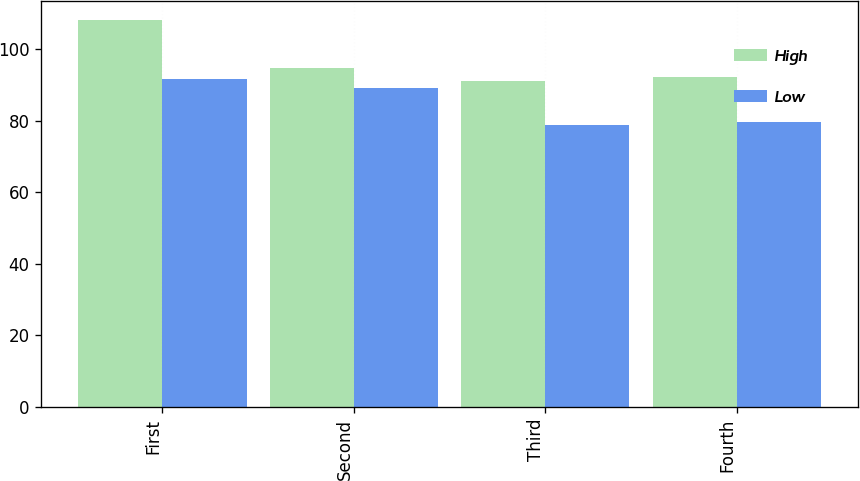Convert chart to OTSL. <chart><loc_0><loc_0><loc_500><loc_500><stacked_bar_chart><ecel><fcel>First<fcel>Second<fcel>Third<fcel>Fourth<nl><fcel>High<fcel>108.07<fcel>94.74<fcel>91.02<fcel>92.32<nl><fcel>Low<fcel>91.74<fcel>89.17<fcel>78.76<fcel>79.77<nl></chart> 